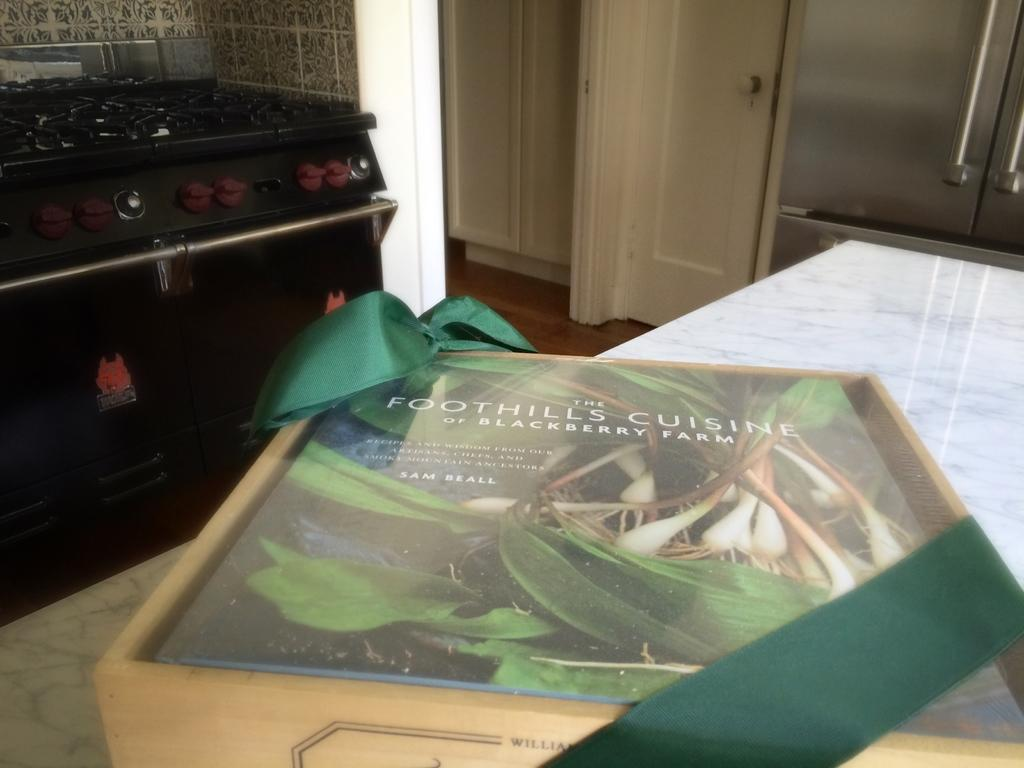<image>
Describe the image concisely. a book that has the word foothills on the cover 